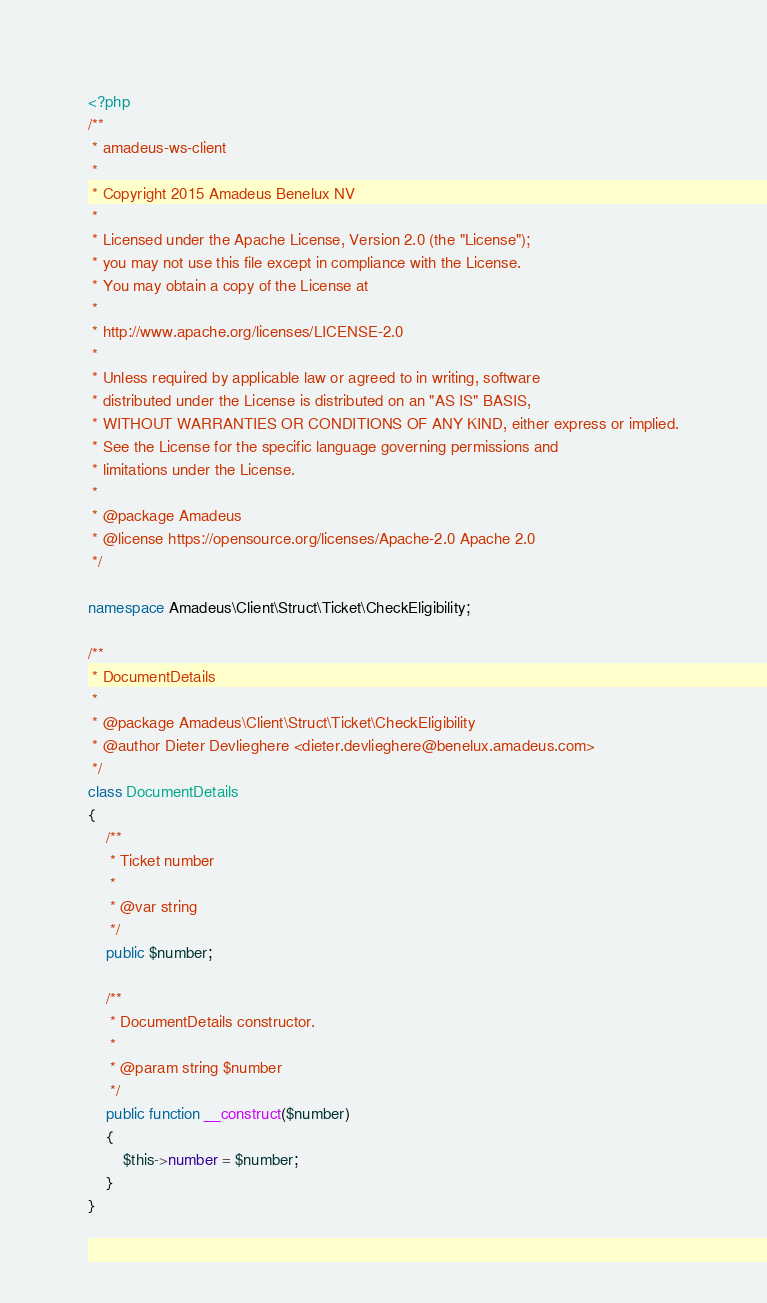<code> <loc_0><loc_0><loc_500><loc_500><_PHP_><?php
/**
 * amadeus-ws-client
 *
 * Copyright 2015 Amadeus Benelux NV
 *
 * Licensed under the Apache License, Version 2.0 (the "License");
 * you may not use this file except in compliance with the License.
 * You may obtain a copy of the License at
 *
 * http://www.apache.org/licenses/LICENSE-2.0
 *
 * Unless required by applicable law or agreed to in writing, software
 * distributed under the License is distributed on an "AS IS" BASIS,
 * WITHOUT WARRANTIES OR CONDITIONS OF ANY KIND, either express or implied.
 * See the License for the specific language governing permissions and
 * limitations under the License.
 *
 * @package Amadeus
 * @license https://opensource.org/licenses/Apache-2.0 Apache 2.0
 */

namespace Amadeus\Client\Struct\Ticket\CheckEligibility;

/**
 * DocumentDetails
 *
 * @package Amadeus\Client\Struct\Ticket\CheckEligibility
 * @author Dieter Devlieghere <dieter.devlieghere@benelux.amadeus.com>
 */
class DocumentDetails
{
    /**
     * Ticket number
     *
     * @var string
     */
    public $number;

    /**
     * DocumentDetails constructor.
     *
     * @param string $number
     */
    public function __construct($number)
    {
        $this->number = $number;
    }
}
</code> 